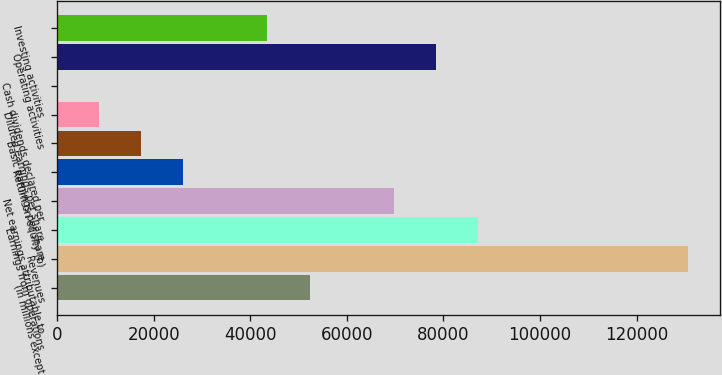Convert chart to OTSL. <chart><loc_0><loc_0><loc_500><loc_500><bar_chart><fcel>(in millions except<fcel>Revenues<fcel>Earnings from operations<fcel>Net earnings attributable to<fcel>Return on equity (b)<fcel>Basic earnings per share<fcel>Diluted earnings per share<fcel>Cash dividends declared per<fcel>Operating activities<fcel>Investing activities<nl><fcel>52282.8<fcel>130707<fcel>87138<fcel>69710.4<fcel>26141.4<fcel>17427.6<fcel>8713.83<fcel>0.03<fcel>78424.2<fcel>43569<nl></chart> 